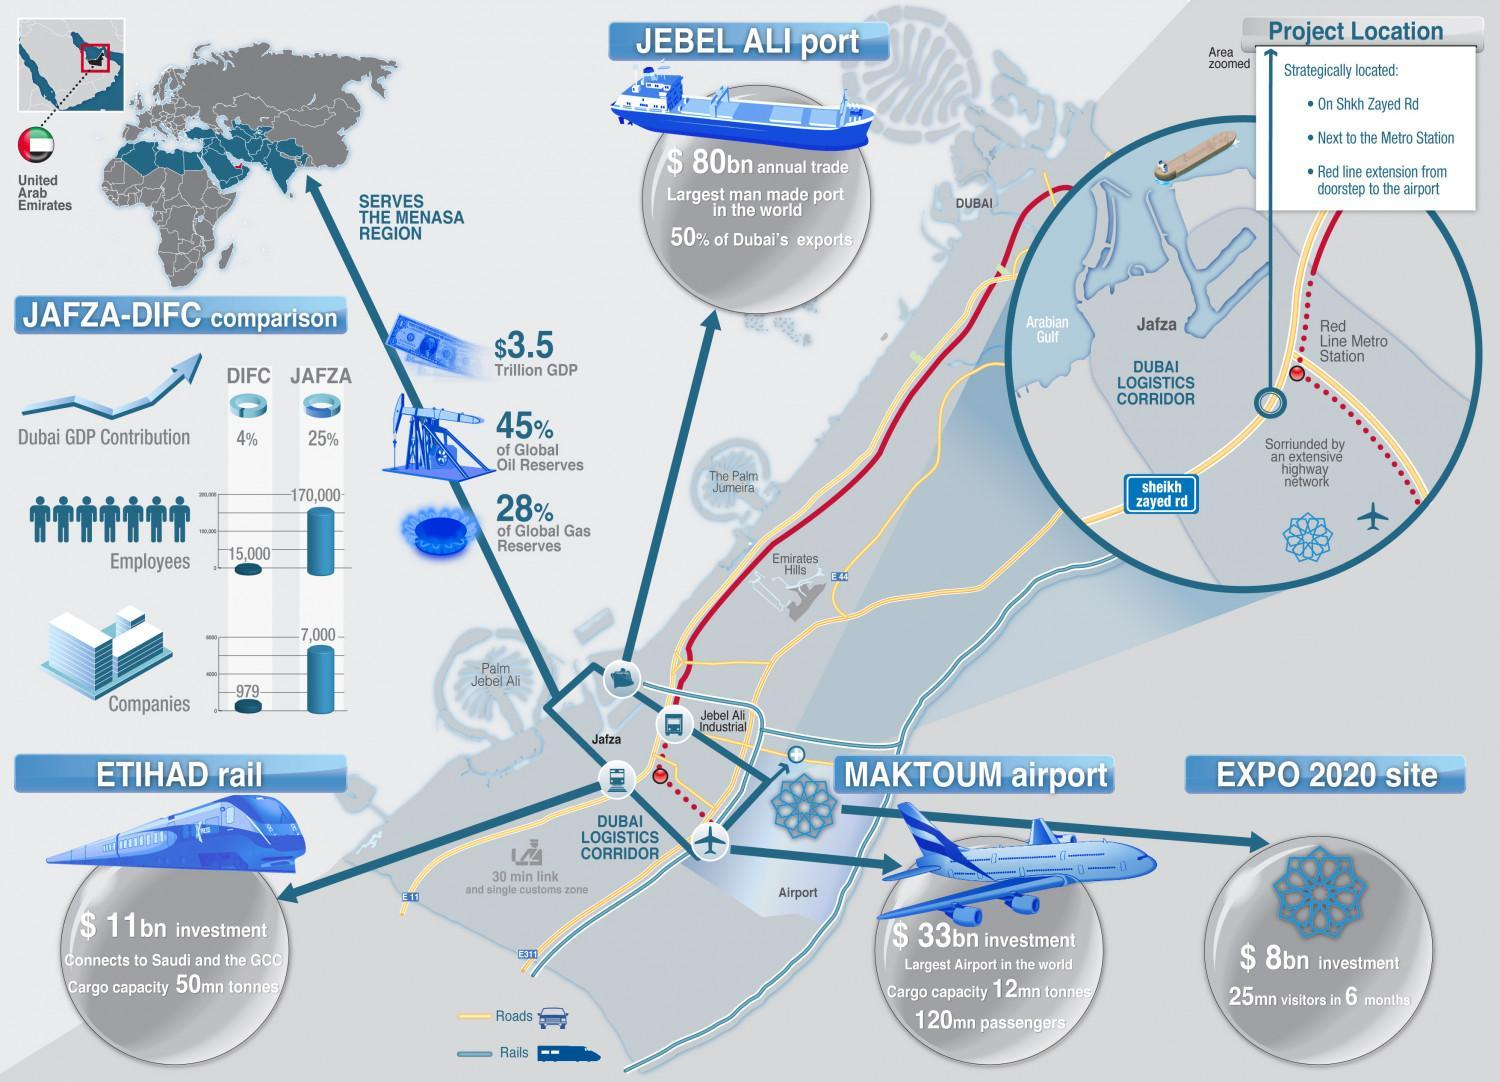What is the total number of companies in JAFZA and IFC?
Answer the question with a short phrase. 7979 What is the difference between employees in JAFZA and IFC? 155000 What is the percentage of global oil reserves and gas reserves when taken together? 73% 